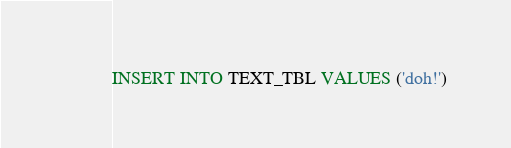<code> <loc_0><loc_0><loc_500><loc_500><_SQL_>INSERT INTO TEXT_TBL VALUES ('doh!')
</code> 